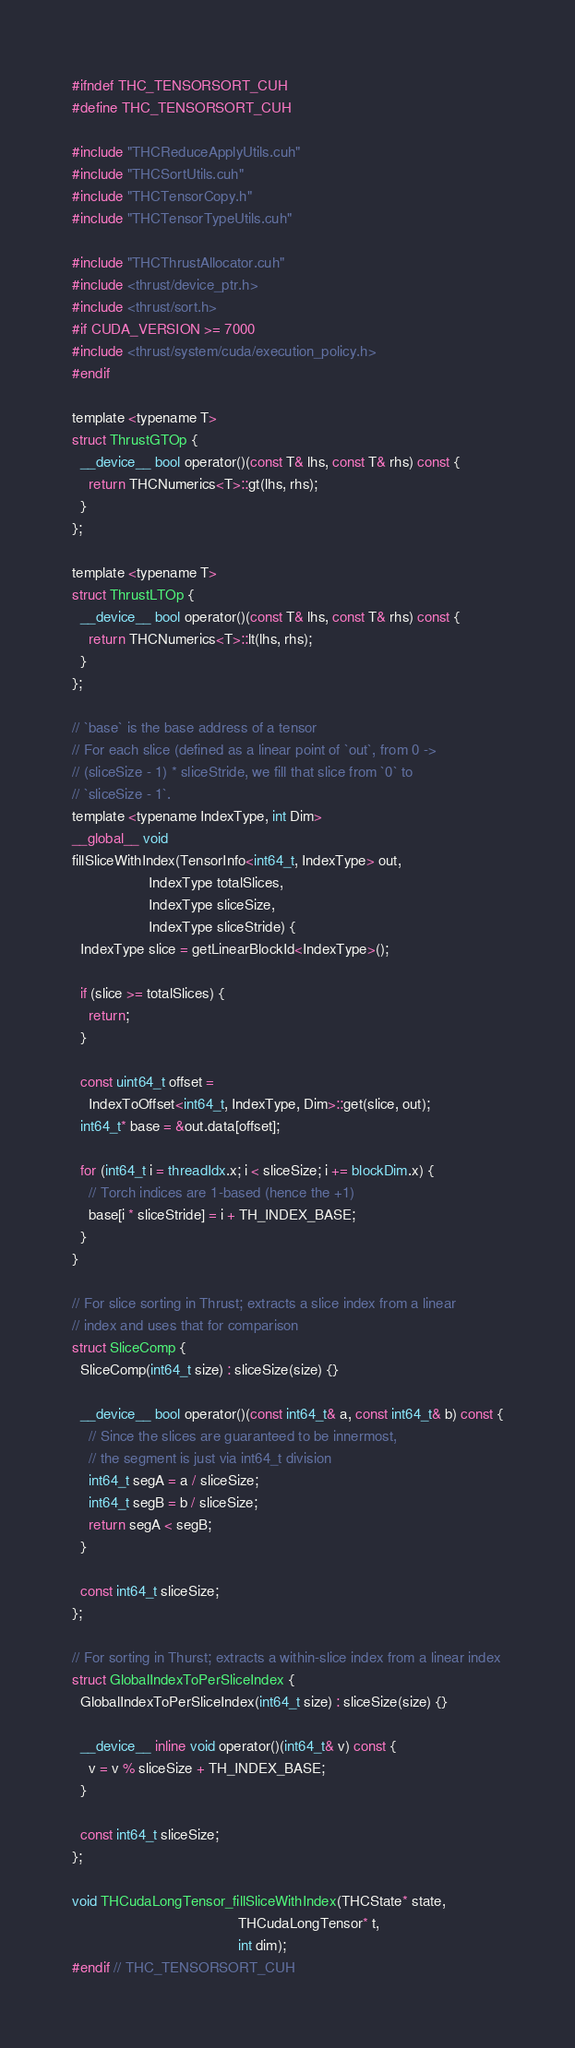<code> <loc_0><loc_0><loc_500><loc_500><_Cuda_>#ifndef THC_TENSORSORT_CUH
#define THC_TENSORSORT_CUH

#include "THCReduceApplyUtils.cuh"
#include "THCSortUtils.cuh"
#include "THCTensorCopy.h"
#include "THCTensorTypeUtils.cuh"

#include "THCThrustAllocator.cuh"
#include <thrust/device_ptr.h>
#include <thrust/sort.h>
#if CUDA_VERSION >= 7000
#include <thrust/system/cuda/execution_policy.h>
#endif

template <typename T>
struct ThrustGTOp {
  __device__ bool operator()(const T& lhs, const T& rhs) const {
    return THCNumerics<T>::gt(lhs, rhs);
  }
};

template <typename T>
struct ThrustLTOp {
  __device__ bool operator()(const T& lhs, const T& rhs) const {
    return THCNumerics<T>::lt(lhs, rhs);
  }
};

// `base` is the base address of a tensor
// For each slice (defined as a linear point of `out`, from 0 ->
// (sliceSize - 1) * sliceStride, we fill that slice from `0` to
// `sliceSize - 1`.
template <typename IndexType, int Dim>
__global__ void
fillSliceWithIndex(TensorInfo<int64_t, IndexType> out,
                   IndexType totalSlices,
                   IndexType sliceSize,
                   IndexType sliceStride) {
  IndexType slice = getLinearBlockId<IndexType>();

  if (slice >= totalSlices) {
    return;
  }

  const uint64_t offset =
    IndexToOffset<int64_t, IndexType, Dim>::get(slice, out);
  int64_t* base = &out.data[offset];

  for (int64_t i = threadIdx.x; i < sliceSize; i += blockDim.x) {
    // Torch indices are 1-based (hence the +1)
    base[i * sliceStride] = i + TH_INDEX_BASE;
  }
}

// For slice sorting in Thrust; extracts a slice index from a linear
// index and uses that for comparison
struct SliceComp {
  SliceComp(int64_t size) : sliceSize(size) {}

  __device__ bool operator()(const int64_t& a, const int64_t& b) const {
    // Since the slices are guaranteed to be innermost,
    // the segment is just via int64_t division
    int64_t segA = a / sliceSize;
    int64_t segB = b / sliceSize;
    return segA < segB;
  }

  const int64_t sliceSize;
};

// For sorting in Thurst; extracts a within-slice index from a linear index
struct GlobalIndexToPerSliceIndex {
  GlobalIndexToPerSliceIndex(int64_t size) : sliceSize(size) {}

  __device__ inline void operator()(int64_t& v) const {
    v = v % sliceSize + TH_INDEX_BASE;
  }

  const int64_t sliceSize;
};

void THCudaLongTensor_fillSliceWithIndex(THCState* state,
                                         THCudaLongTensor* t,
                                         int dim);
#endif // THC_TENSORSORT_CUH
</code> 